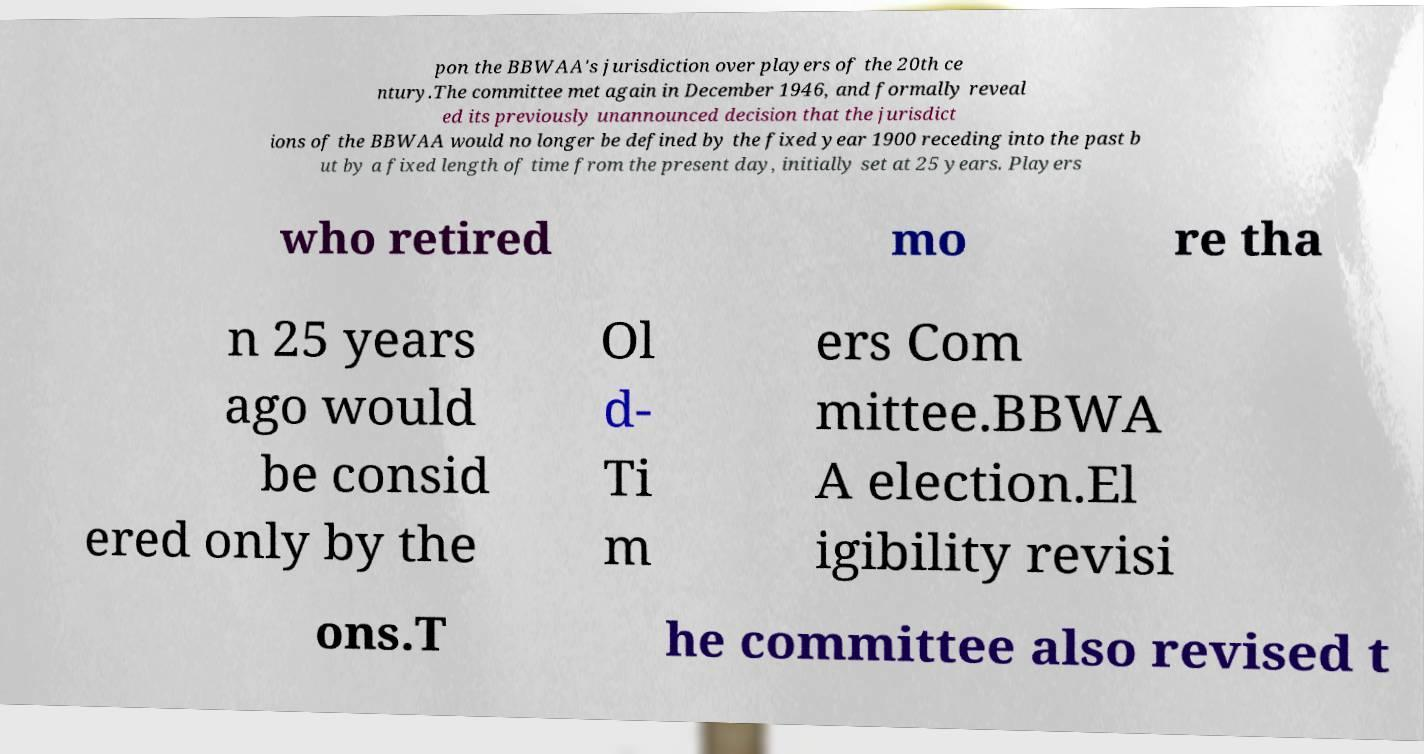There's text embedded in this image that I need extracted. Can you transcribe it verbatim? pon the BBWAA's jurisdiction over players of the 20th ce ntury.The committee met again in December 1946, and formally reveal ed its previously unannounced decision that the jurisdict ions of the BBWAA would no longer be defined by the fixed year 1900 receding into the past b ut by a fixed length of time from the present day, initially set at 25 years. Players who retired mo re tha n 25 years ago would be consid ered only by the Ol d- Ti m ers Com mittee.BBWA A election.El igibility revisi ons.T he committee also revised t 